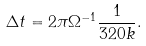<formula> <loc_0><loc_0><loc_500><loc_500>\Delta t = 2 \pi \Omega ^ { - 1 } \frac { 1 } { 3 2 0 k } .</formula> 